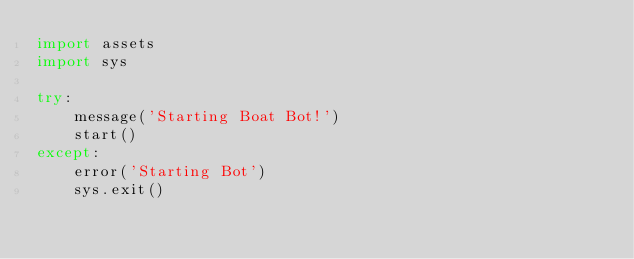<code> <loc_0><loc_0><loc_500><loc_500><_Python_>import assets
import sys

try:
	message('Starting Boat Bot!')
	start()
except:
	error('Starting Bot')
	sys.exit()
</code> 